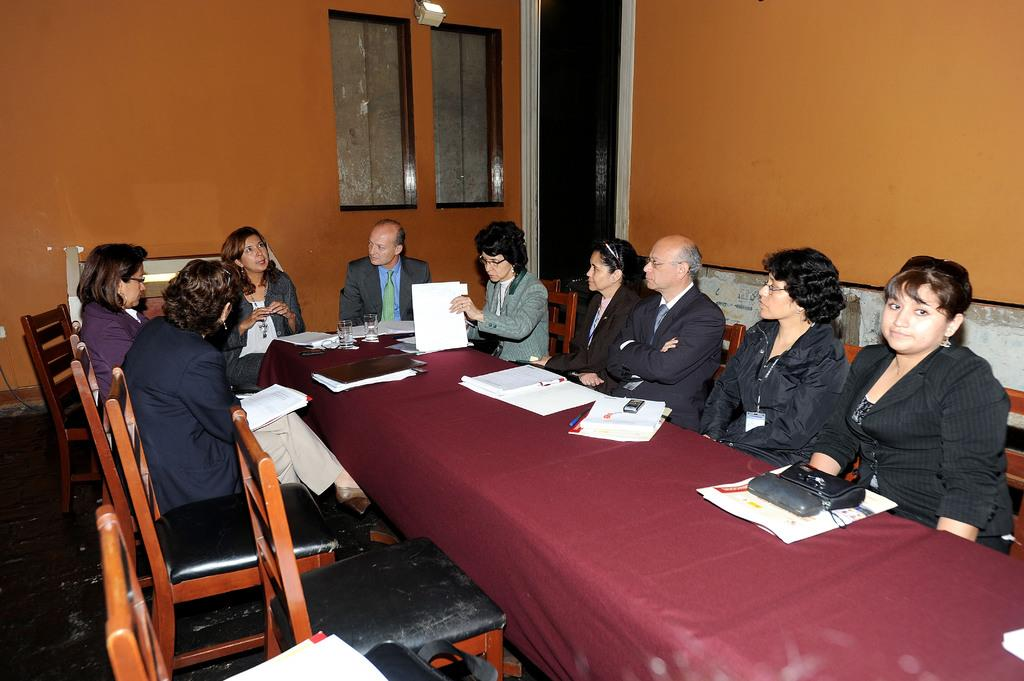What are the persons in the image doing? The persons in the image are sitting around the table. What objects can be seen on the table? There is a handbag, papers, books, and glasses on the table. What is visible in the background of the image? There is a wall and windows in the background of the image. Can you tell me what the man's grandmother is doing in the image? There is no man or grandmother present in the image. What type of snail can be seen crawling on the table in the image? There is no snail present in the image; the table only contains a handbag, papers, books, and glasses. 